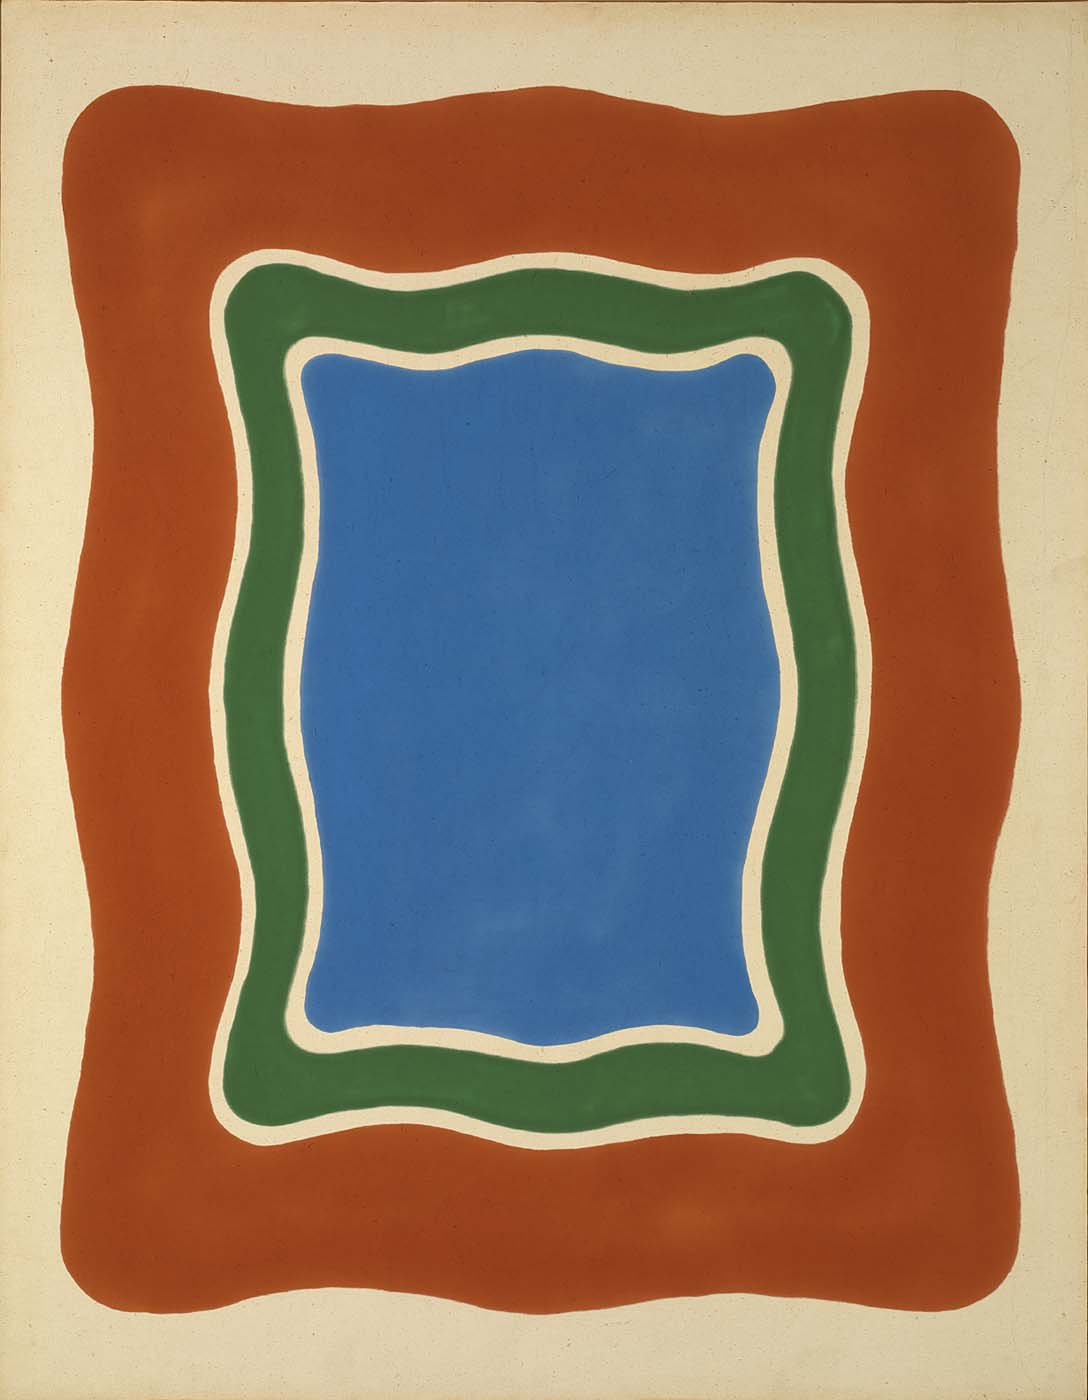Describe a realistic scenario where this artwork fits perfectly. This artwork could be perfectly situated in a modern, minimalist living room, serving as a striking focal point that brings vibrancy and energy to the space. Its bold colors and simple geometric forms would complement clean, uncluttered lines and neutral furnishings, creating a harmonious balance between sophistication and warmth. Alternatively, it could hang in a contemporary art gallery, drawing viewers in with its dynamic interplay of color and form, sparking conversation and contemplation. 